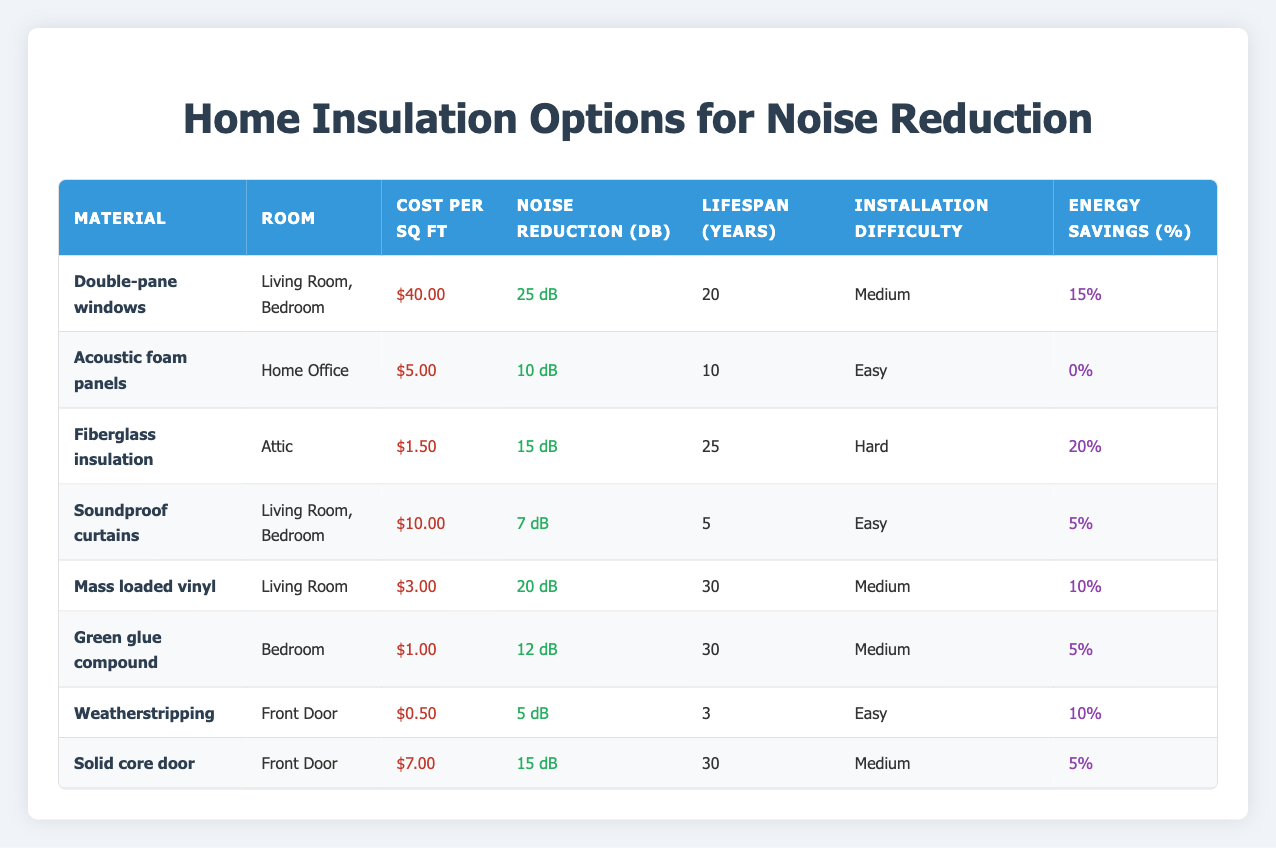What is the cost per square foot for Double-pane windows? According to the table, the cost per square foot for Double-pane windows is listed as $40.00.
Answer: $40.00 What installation difficulty is associated with fiberglass insulation? The table indicates that the installation difficulty for fiberglass insulation is categorized as "Hard."
Answer: Hard Which material offers the highest noise reduction in decibels (dB)? By comparing the noise reduction values listed in the table, Double-pane windows provide the highest reduction at 25 dB.
Answer: Double-pane windows What is the lifespan of soundproof curtains? The lifespan for soundproof curtains according to the table is stated as 5 years.
Answer: 5 years Are mass loaded vinyl and solid core door both classified as medium difficulty for installation? By examining the installation difficulty sections for both materials in the table, mass loaded vinyl is marked as "Medium" and so is solid core door. Thus, the statement is true.
Answer: Yes What is the average cost per square foot for all insulation materials listed? To find the average cost, add the costs listed: (40 + 5 + 1.5 + 10 + 3 + 1 + 0.5 + 7) = 68. The number of materials is 8, so the average cost is 68/8 = 8.5.
Answer: $8.50 Is there any material that provides more than 20 dB noise reduction and has an easy installation difficulty? Reviewing the materials in the table, both mass loaded vinyl (20 dB) and others exceed 20 dB but have varying installation difficulties; none listed as easy installation offers more than 20 dB noise reduction. Hence, the answer is false.
Answer: No What percentage of energy savings does fiberglass insulation provide? According to the table, fiberglass insulation offers a 20% energy savings.
Answer: 20% Which room has the most insulation options listed? By counting the room entries, the Living Room has three insulation options (Double-pane windows, soundproof curtains, mass loaded vinyl) compared to the others.
Answer: Living Room 